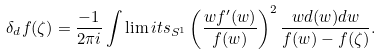<formula> <loc_0><loc_0><loc_500><loc_500>\delta _ { d } f ( \zeta ) = \frac { - 1 } { 2 \pi i } \int \lim i t s _ { S ^ { 1 } } \left ( \frac { w f ^ { \prime } ( w ) } { f ( w ) } \right ) ^ { 2 } \frac { w d ( w ) d w } { f ( w ) - f ( \zeta ) } .</formula> 